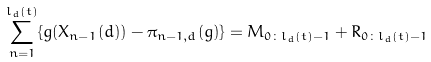Convert formula to latex. <formula><loc_0><loc_0><loc_500><loc_500>\sum _ { n = 1 } ^ { l _ { d } ( t ) } \{ { g } ( X _ { n - 1 } ( d ) ) - \pi _ { n - 1 , d } ( { g } ) \} = M _ { 0 \colon l _ { d } ( t ) - 1 } + R _ { 0 \colon l _ { d } ( t ) - 1 }</formula> 